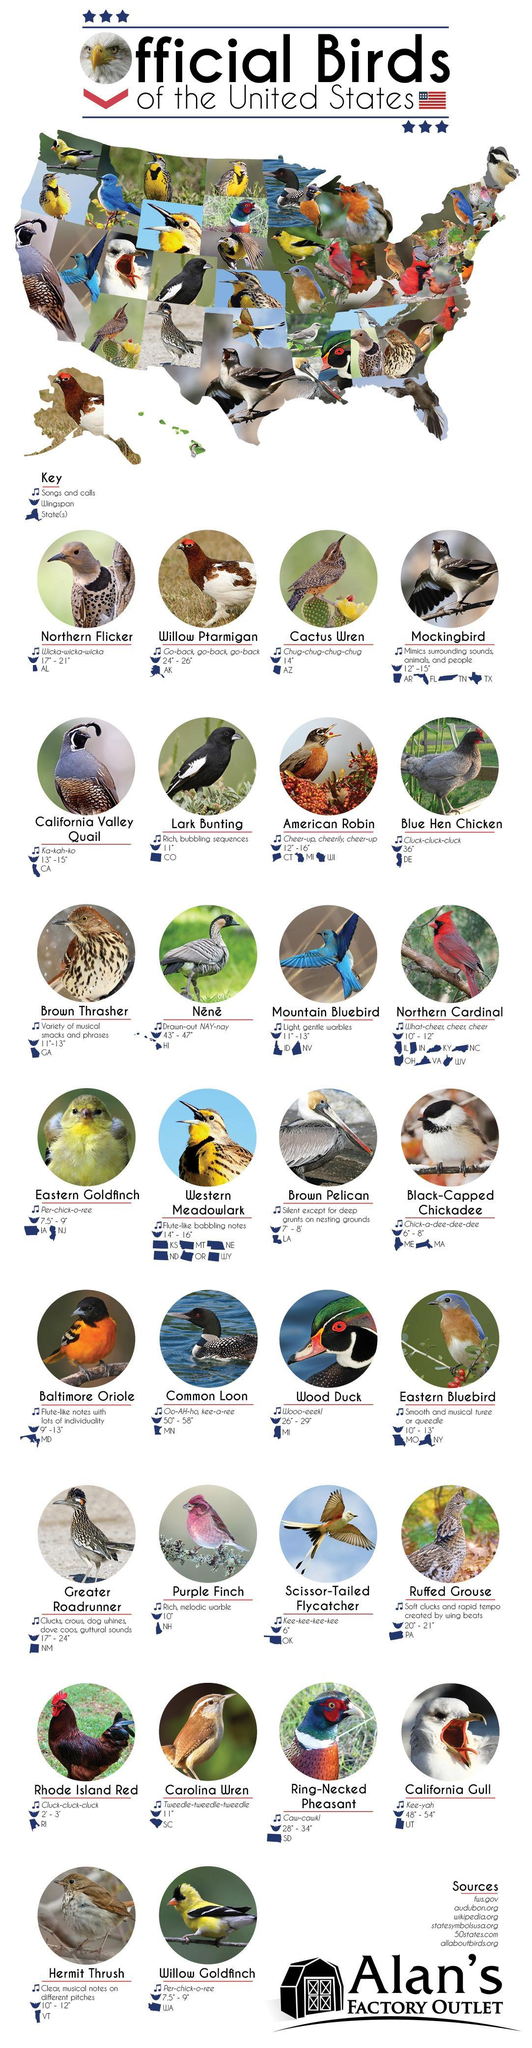What is the song of "Blue Hen Chicken"?
Answer the question with a short phrase. Cluck-cluck-cluck In which state Ruffed Grouse is seen? PA What is the wingspan of northern Flicker? 17"- 21" What is the wingspan of Great Roadrunner? 17"-24" How is the song of Common Loon? Oo-AH-ho, kee-a-ree What is the song/call of Purple Finch? Rich, melodic warble In which state the bird Willow Ptarmigan is found? AK In which state the bird Cactus Wren is found? AZ What is the wingspan of Hermit Thrush? 10"-12" In how many states Western Meadowlark is found? 6 